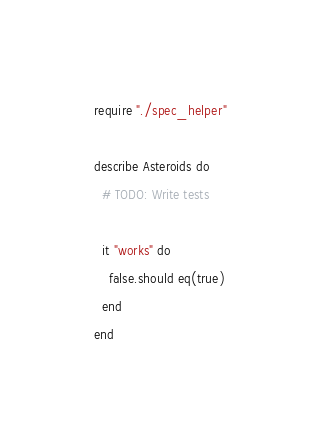Convert code to text. <code><loc_0><loc_0><loc_500><loc_500><_Crystal_>require "./spec_helper"

describe Asteroids do
  # TODO: Write tests

  it "works" do
    false.should eq(true)
  end
end
</code> 